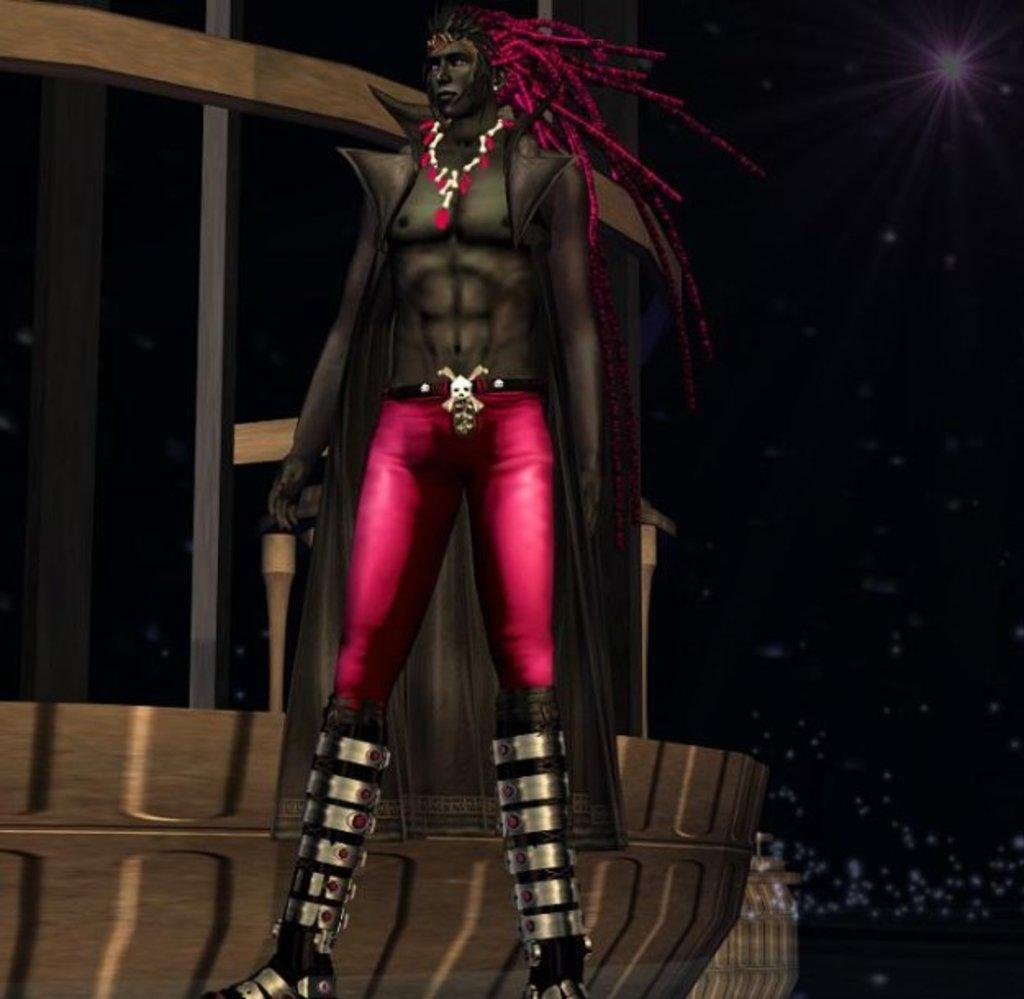What type of character is depicted in the image? There is a cartoon of a man in the image. What is the man wearing on his lower body? The man is wearing pink trousers. What accessory is the man wearing? The man is wearing an ornament. What can be seen in the distance behind the man? There is a building in the background of the image. How is the spoon used in the distribution of the man's ornament in the image? There is no spoon present in the image, and the man's ornament is not being distributed. 